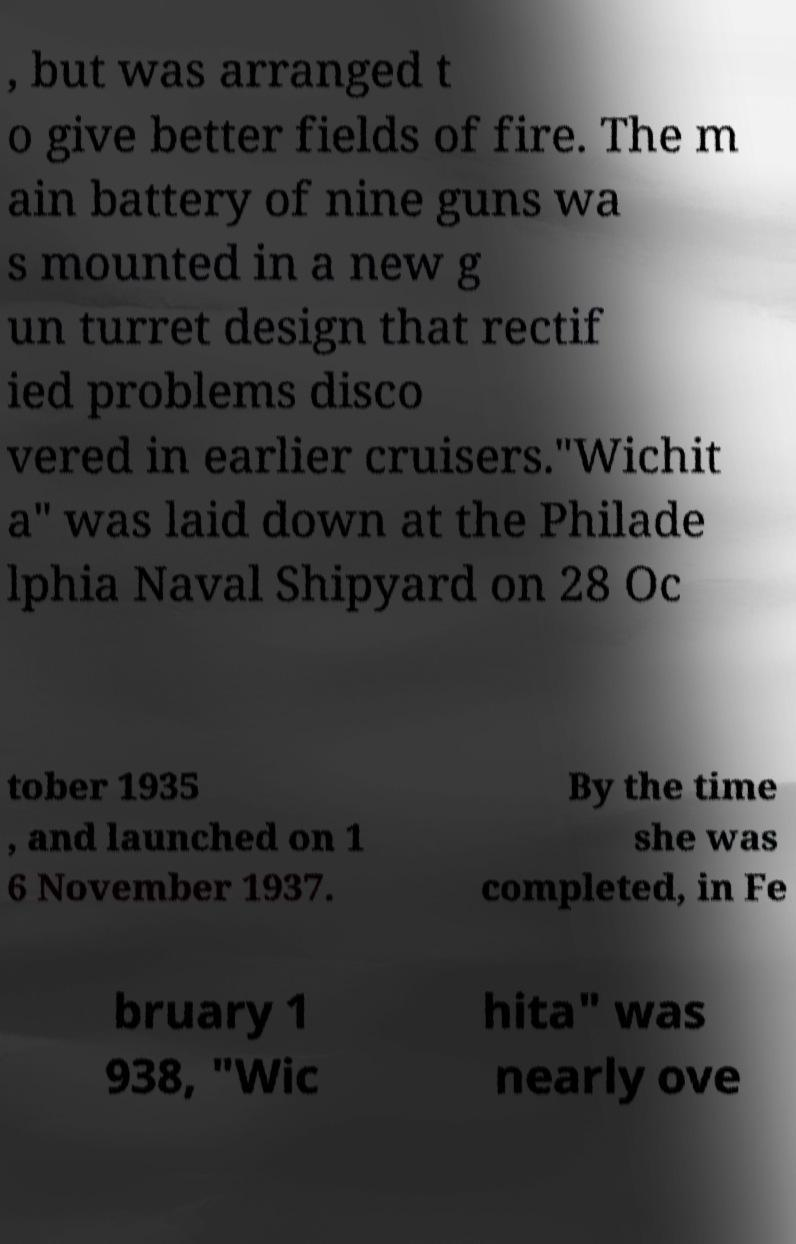Can you read and provide the text displayed in the image?This photo seems to have some interesting text. Can you extract and type it out for me? , but was arranged t o give better fields of fire. The m ain battery of nine guns wa s mounted in a new g un turret design that rectif ied problems disco vered in earlier cruisers."Wichit a" was laid down at the Philade lphia Naval Shipyard on 28 Oc tober 1935 , and launched on 1 6 November 1937. By the time she was completed, in Fe bruary 1 938, "Wic hita" was nearly ove 